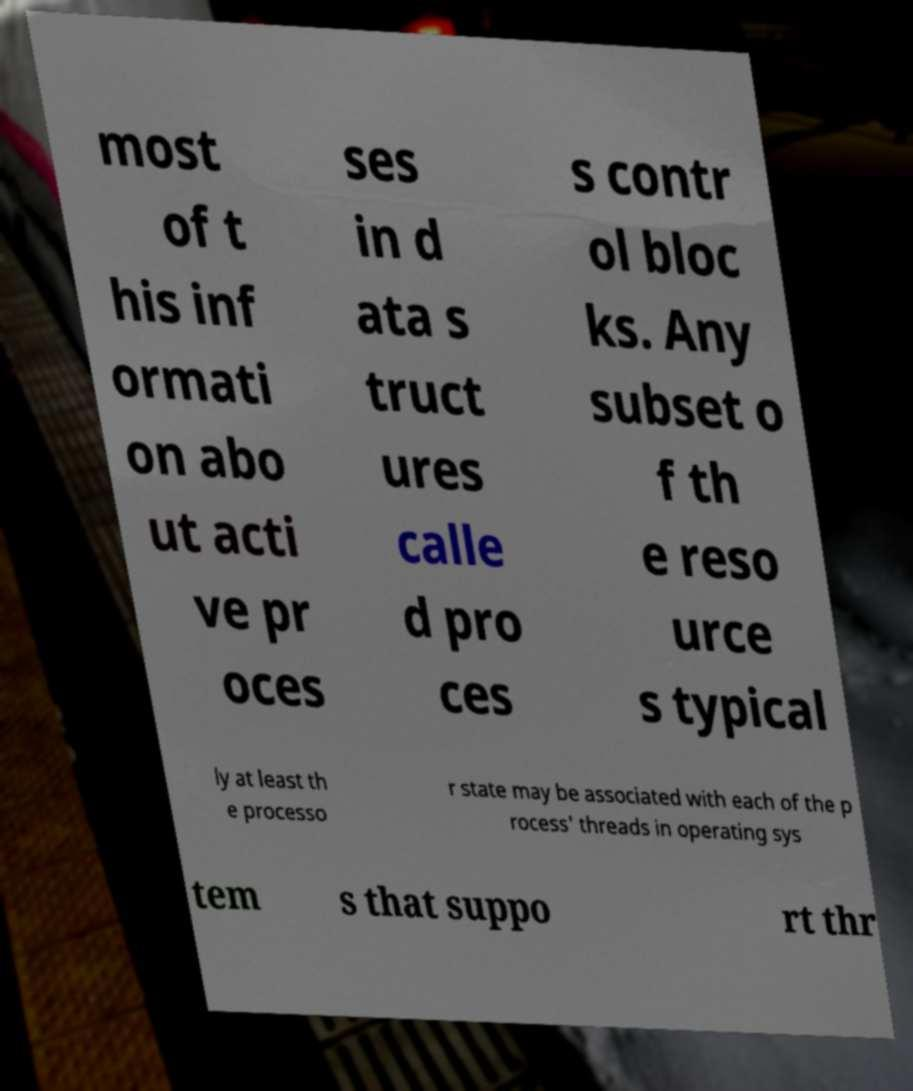I need the written content from this picture converted into text. Can you do that? most of t his inf ormati on abo ut acti ve pr oces ses in d ata s truct ures calle d pro ces s contr ol bloc ks. Any subset o f th e reso urce s typical ly at least th e processo r state may be associated with each of the p rocess' threads in operating sys tem s that suppo rt thr 